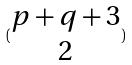<formula> <loc_0><loc_0><loc_500><loc_500>( \begin{matrix} p + q + 3 \\ 2 \end{matrix} )</formula> 